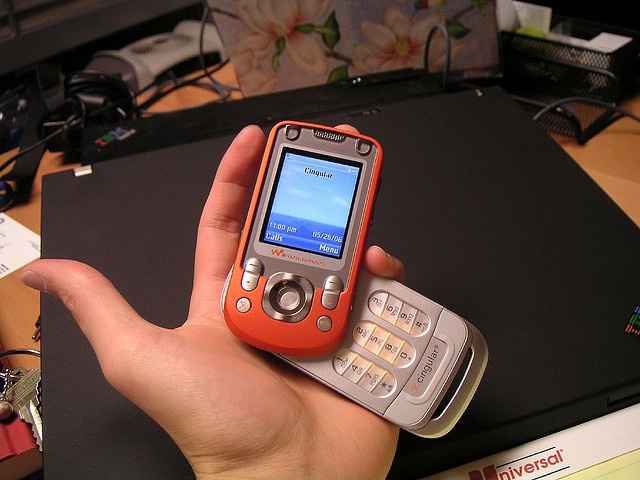Describe the objects in this image and their specific colors. I can see laptop in black, salmon, and brown tones, people in black and salmon tones, cell phone in black, lightblue, gray, and red tones, and cell phone in black, tan, darkgray, maroon, and gray tones in this image. 